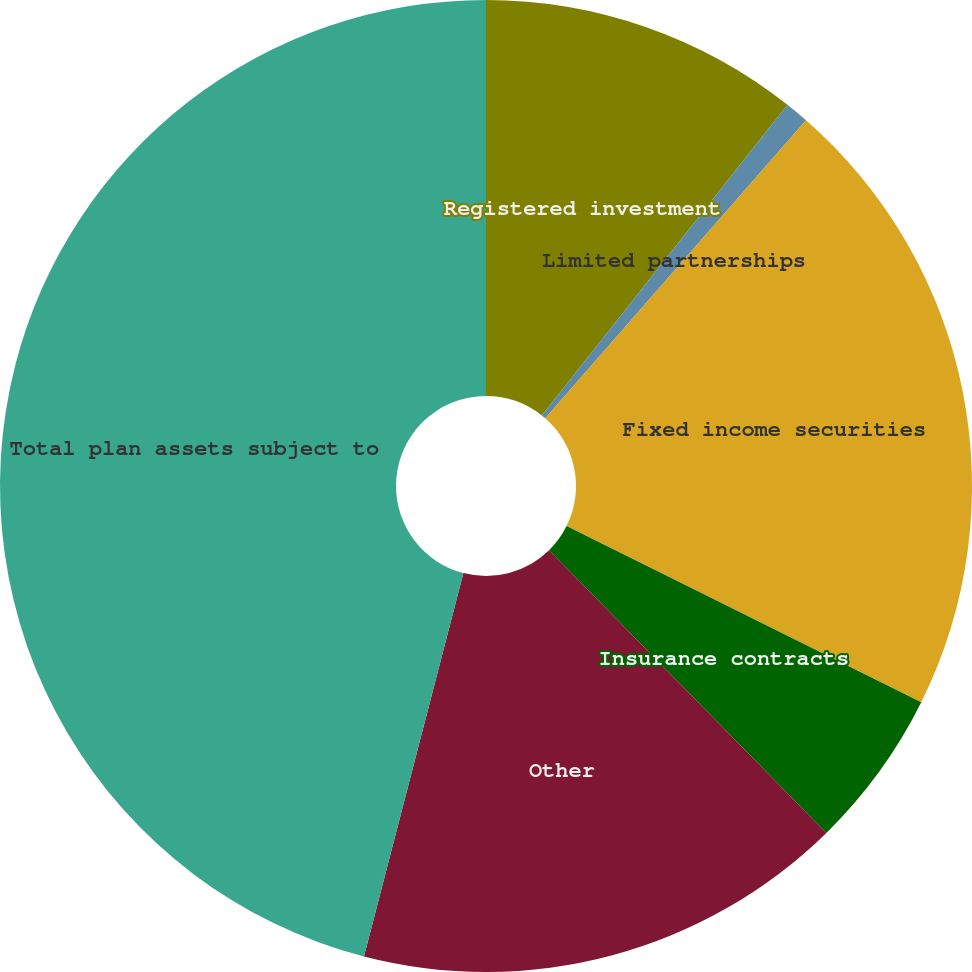Convert chart to OTSL. <chart><loc_0><loc_0><loc_500><loc_500><pie_chart><fcel>Registered investment<fcel>Limited partnerships<fcel>Fixed income securities<fcel>Insurance contracts<fcel>Other<fcel>Total plan assets subject to<nl><fcel>10.65%<fcel>0.79%<fcel>20.9%<fcel>5.31%<fcel>16.39%<fcel>45.96%<nl></chart> 